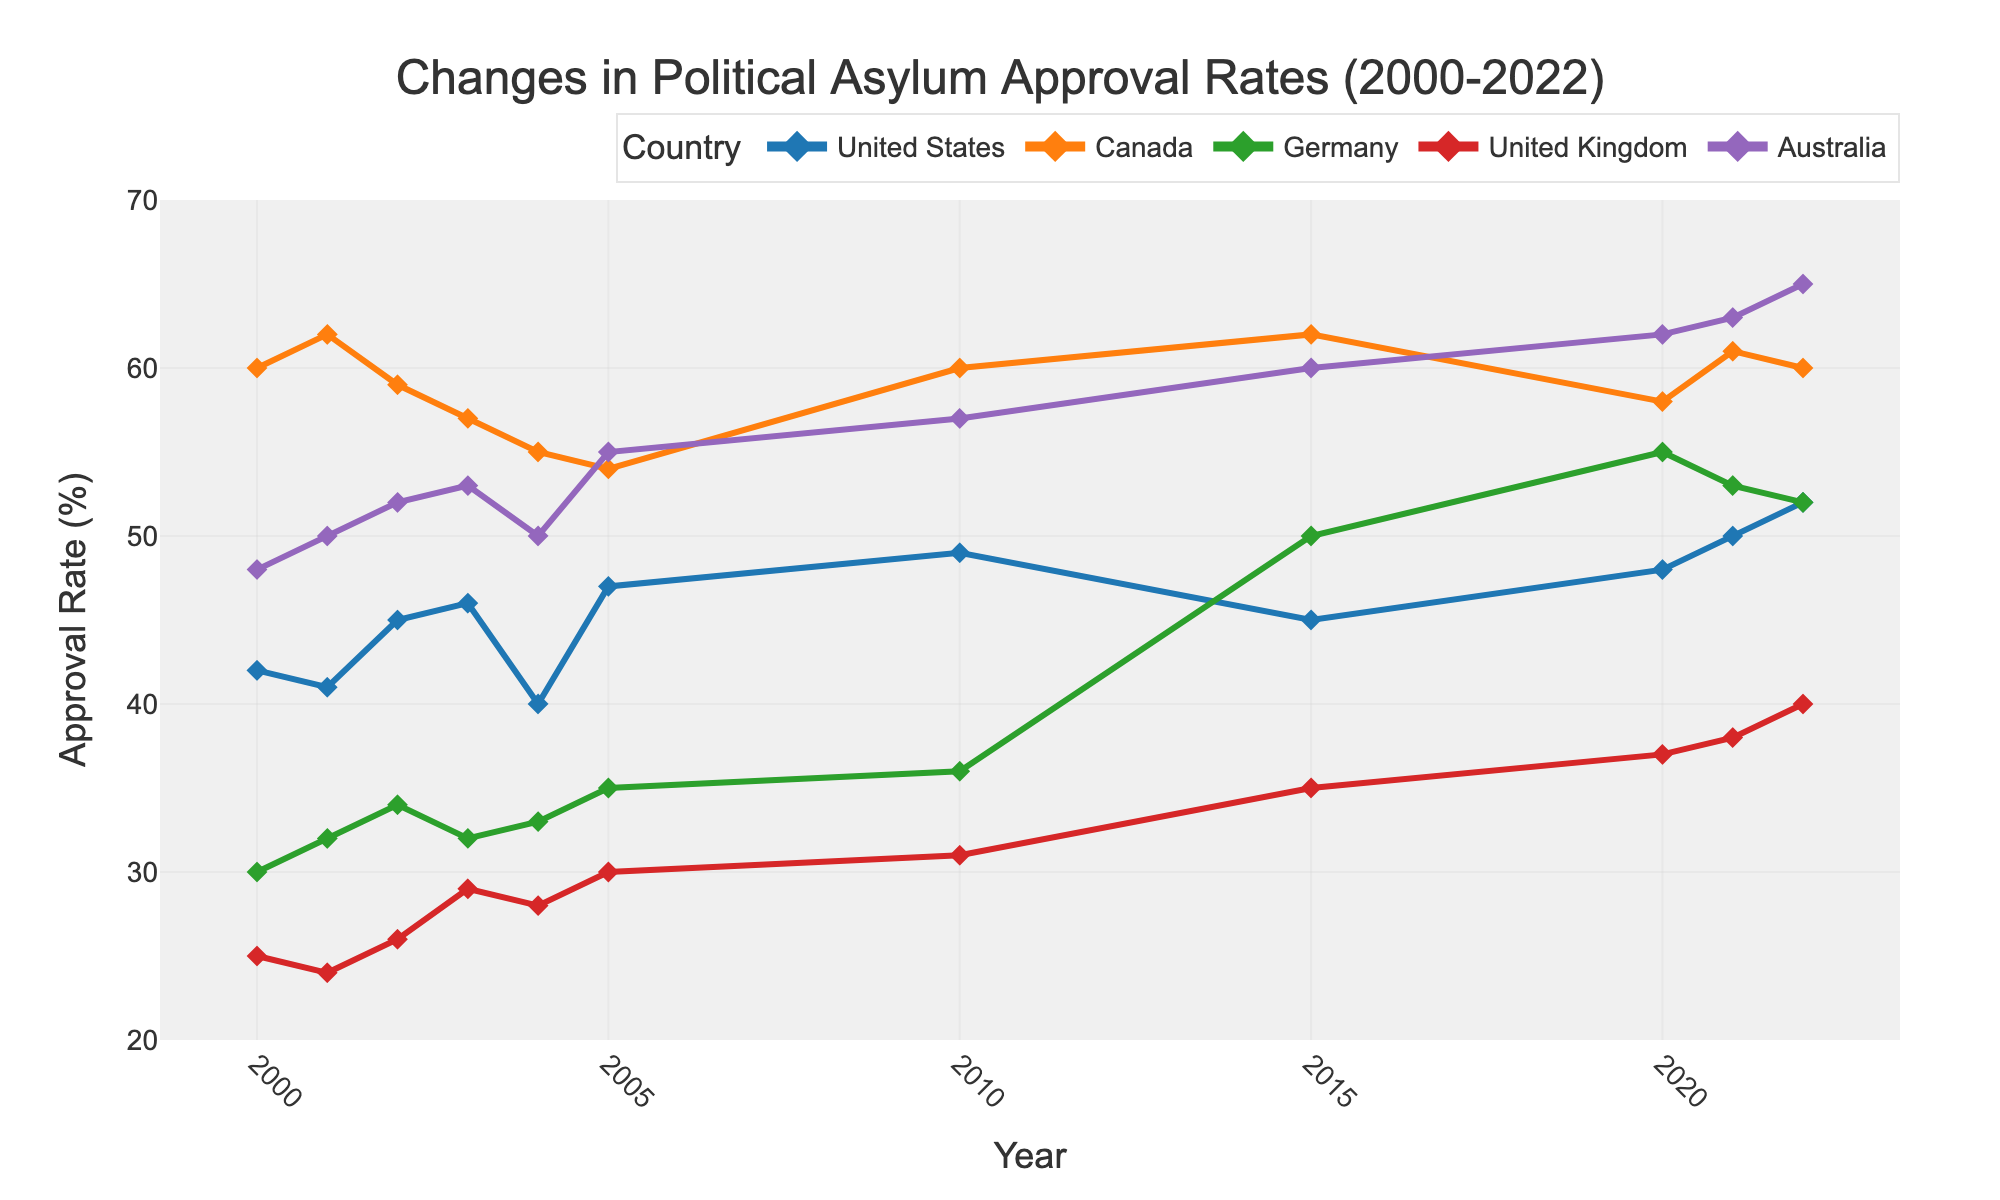What is the title of the plot? The title is located at the top center of the plot and it provides a brief description of the data being visualized.
Answer: Changes in Political Asylum Approval Rates (2000-2022) How many countries are represented in the plot? The legend on the right-hand side lists all the countries being represented by different colored lines.
Answer: Five Which country had the highest asylum approval rate in 2022? Locate the year 2022 on the x-axis and compare the y-axis values of the different colored lines.
Answer: Australia What is the trend of Canada's asylum approval rate from 2000 to 2022? Analyze the line corresponding to Canada over the years.
Answer: It remains relatively stable with minor fluctuations, trending around 60% Which country experienced the greatest increase in approval rate between any two consecutive data points? Look for the steepest upward slope between two consecutive years for any country.
Answer: Germany between 2010 and 2015 What is the average approval rate for Australia from 2010 to 2022? Identify the data points for Australia from 2010 to 2022 and calculate their average: (57 + 60 + 62 + 63 + 65) / 5.
Answer: 61.4 Which countries had an approval rate lower than 30% in 2000? Compare the y-axis values for all countries in the year 2000.
Answer: Germany and United Kingdom Did the United Kingdom's asylum approval rate ever exceed 40%? Examine the data points for the United Kingdom throughout the timeline.
Answer: Yes, in 2022 Which country had the most volatile asylum approval rate from 2000 to 2022? To determine volatility, evaluate the range and frequency of the approval rate changes.
Answer: Germany 